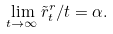<formula> <loc_0><loc_0><loc_500><loc_500>\lim _ { t \to \infty } { \tilde { r } ^ { r } _ { t } } / { t } = \alpha .</formula> 